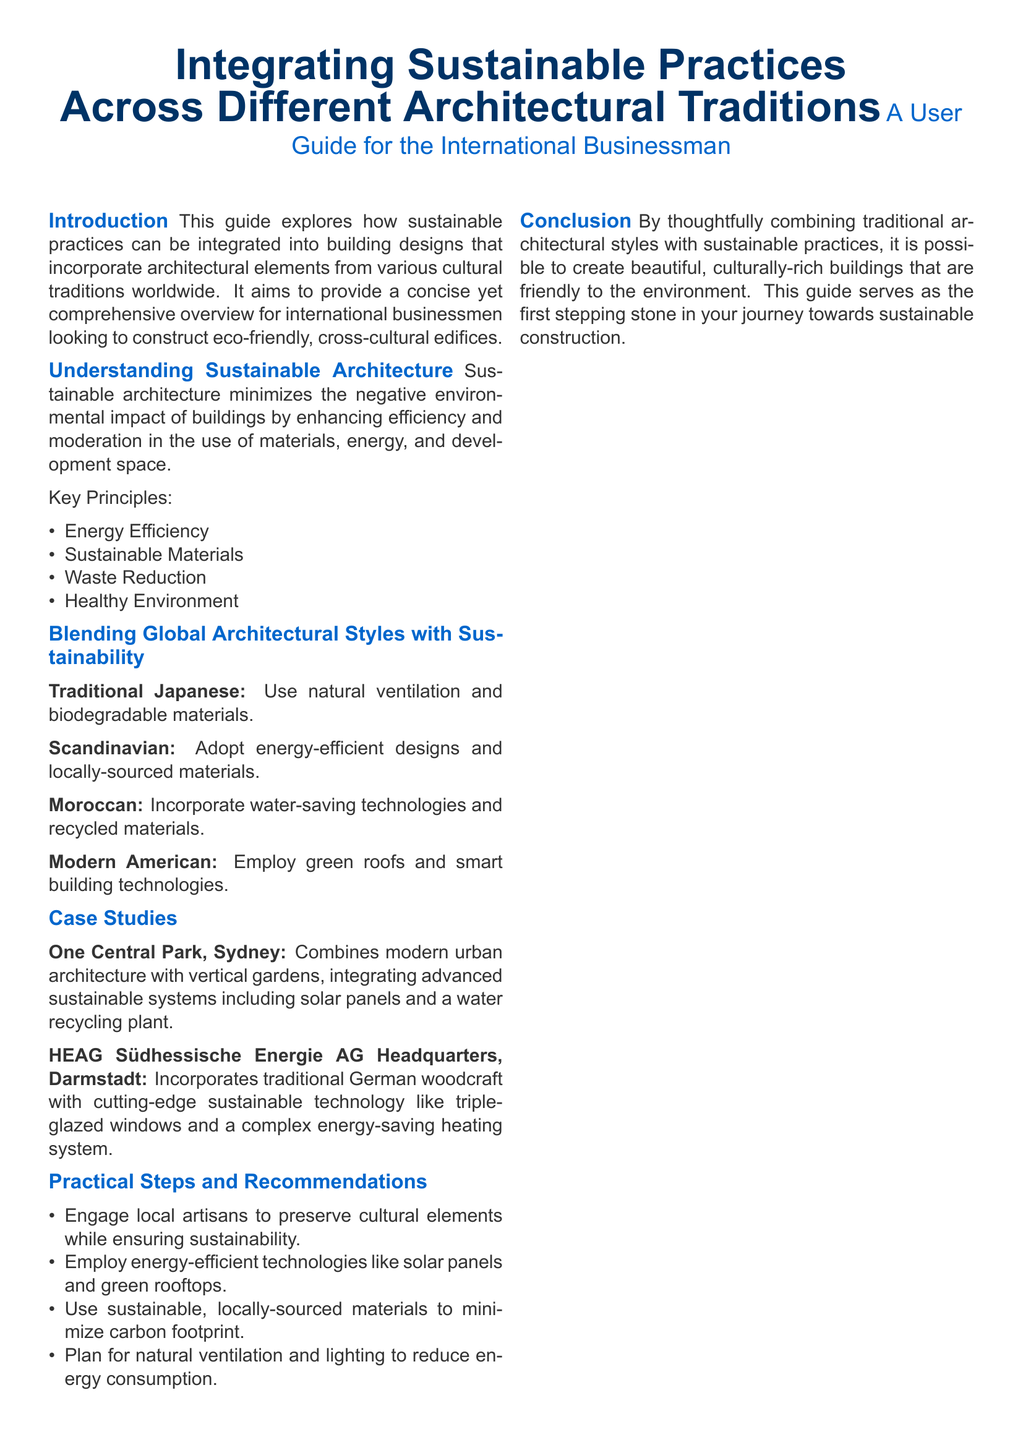what is the title of the document? The title of the document is presented prominently at the beginning, which reflects the main focus of the content.
Answer: Integrating Sustainable Practices Across Different Architectural Traditions what is one key principle of sustainable architecture? The document lists several key principles of sustainable architecture, providing insight into its core values.
Answer: Energy Efficiency which architectural style incorporates water-saving technologies? The document mentions specific architectural styles and their sustainable practices, including those that focus on water-saving technologies.
Answer: Moroccan how many case studies are presented in the document? The document explicitly mentions and describes a couple of case studies, giving examples of sustainable architecture in practice.
Answer: Two what is one recommendation for integrating local culture in architecture? The guide offers practical steps that highlight the importance of local cultural integration in sustainable practices.
Answer: Engage local artisans which city is home to the case study One Central Park? The document identifies the locations associated with the case studies, making it easy to find relevant geographical context.
Answer: Sydney what type of materials does Scandinavian architecture emphasize? The document describes the essence of different architectural styles, detailing the materials that are prioritized in each tradition.
Answer: Locally-sourced materials what type of building technology is suggested for modern American architecture? The document clearly outlines the sustainable technologies proposed within the context of modern American architectural practices.
Answer: Smart building technologies 